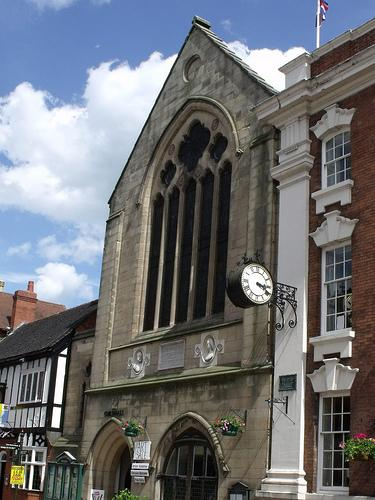How many windows can you count in this image, and how are they distinct from each other? There are six distinct windows, varying in size, shape, and color; some are arched, square, or green. What makes the scene in this image noticeable? A large old stone building with a clock on the side, surrounded by hanging flowers and various window styles, set against a blue sky with white clouds. Mention three distinct colors present in the image. Black and white on the clock, green windows, and pink flowers in the hanging flowerpots. Which kind of weather could you associate with the given image? A sunny day with blue sky and white clouds scattered across the sky. What is the focal point of the image? The focal point is the large old stone building, characterized by the clock on its side, various window styles, and hanging flowerpots. 